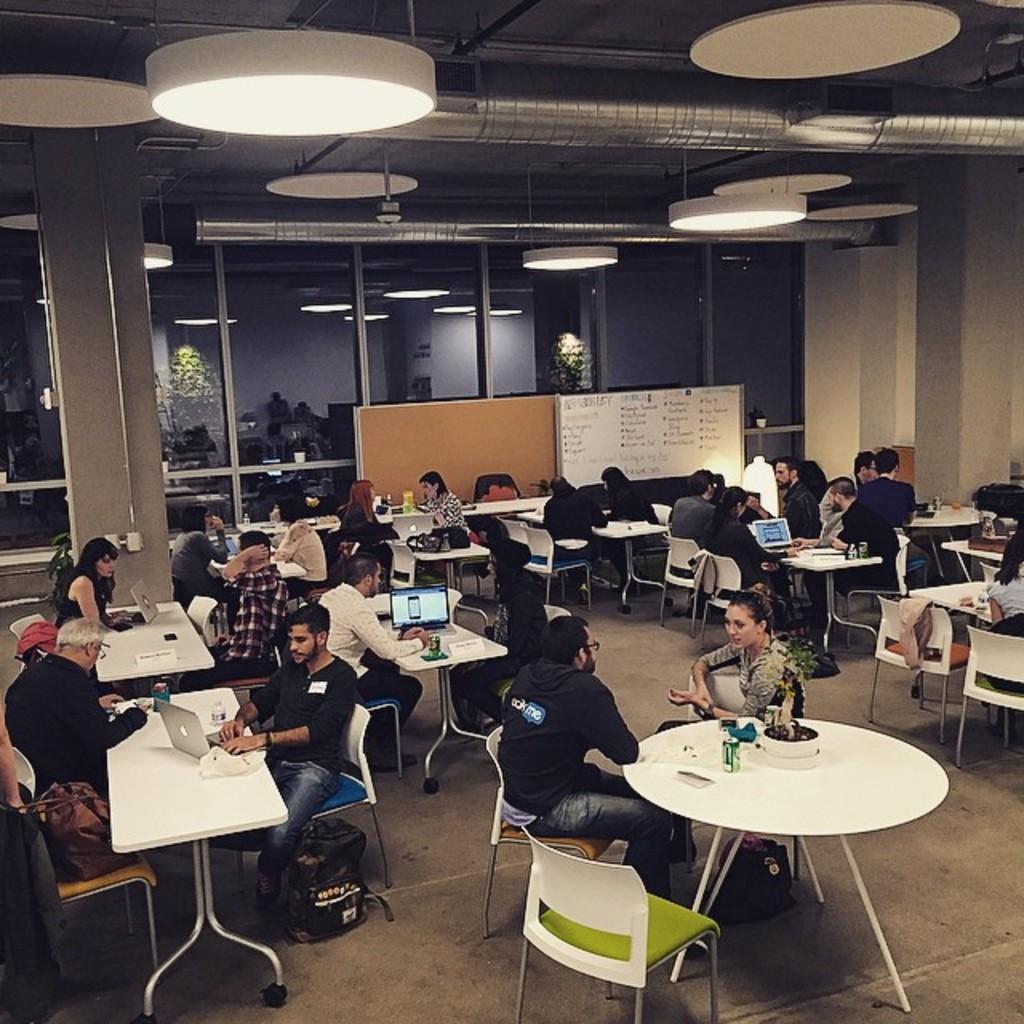Can you describe this image briefly? This image is clicked in a room. There are lights on the top. In the middle there is a whiteboard. There are so many tables and chairs. People are sitting in chairs near the tables. On that table there are laptops ,Water bottles, tissues, mobile phones. 